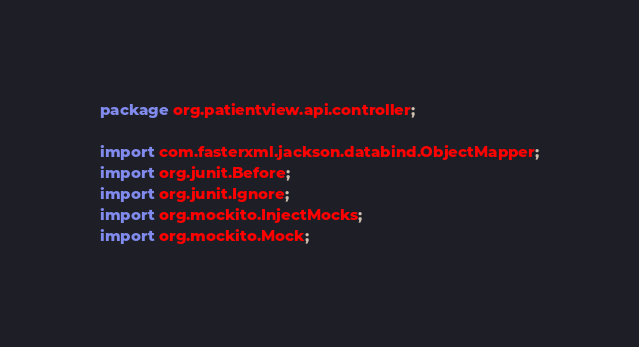<code> <loc_0><loc_0><loc_500><loc_500><_Java_>package org.patientview.api.controller;

import com.fasterxml.jackson.databind.ObjectMapper;
import org.junit.Before;
import org.junit.Ignore;
import org.mockito.InjectMocks;
import org.mockito.Mock;</code> 